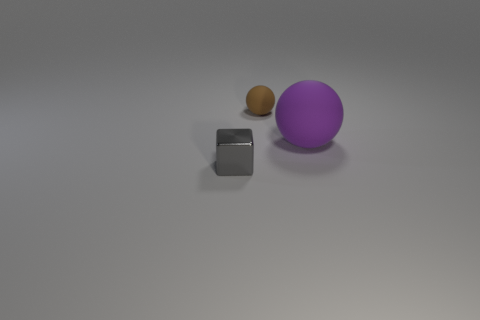Is the number of large purple matte things that are in front of the large rubber thing greater than the number of brown matte spheres?
Your answer should be very brief. No. Is the big purple thing the same shape as the metal thing?
Ensure brevity in your answer.  No. How many small spheres are the same material as the big thing?
Your answer should be compact. 1. The other thing that is the same shape as the brown thing is what size?
Your answer should be compact. Large. Do the brown rubber object and the purple rubber ball have the same size?
Ensure brevity in your answer.  No. There is a thing that is to the left of the rubber thing left of the matte object that is on the right side of the brown rubber sphere; what shape is it?
Provide a short and direct response. Cube. The tiny thing that is the same shape as the large purple matte thing is what color?
Make the answer very short. Brown. There is a thing that is left of the large purple ball and behind the small shiny object; what is its size?
Provide a succinct answer. Small. There is a tiny object on the left side of the tiny object to the right of the small gray shiny block; how many rubber balls are to the left of it?
Offer a terse response. 0. What number of tiny things are spheres or gray cubes?
Provide a succinct answer. 2. 